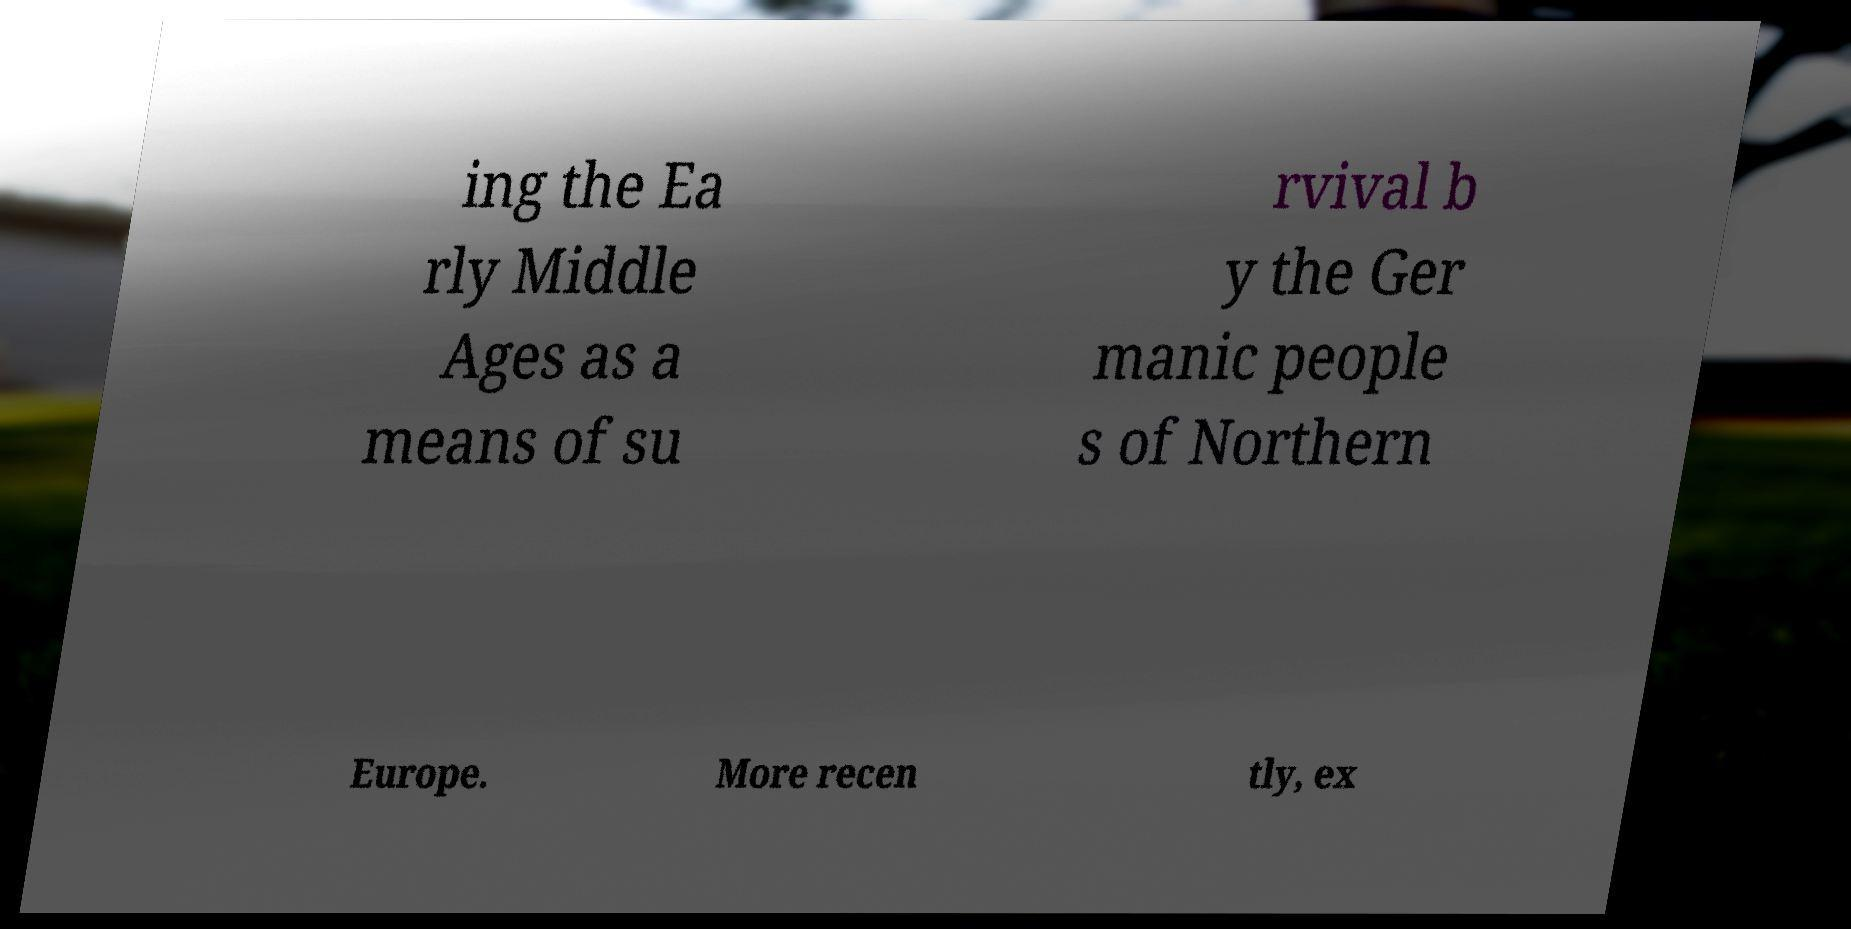I need the written content from this picture converted into text. Can you do that? ing the Ea rly Middle Ages as a means of su rvival b y the Ger manic people s of Northern Europe. More recen tly, ex 